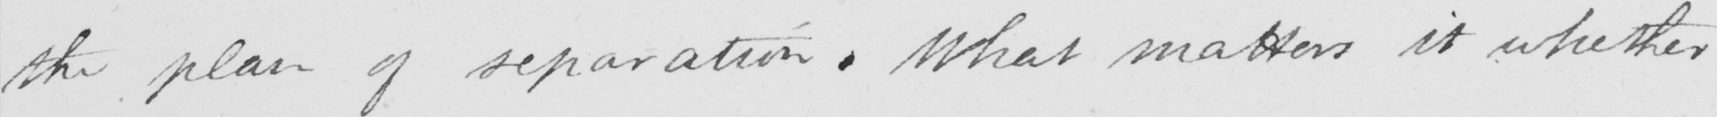Can you read and transcribe this handwriting? the plan of separation . What matters it whether 